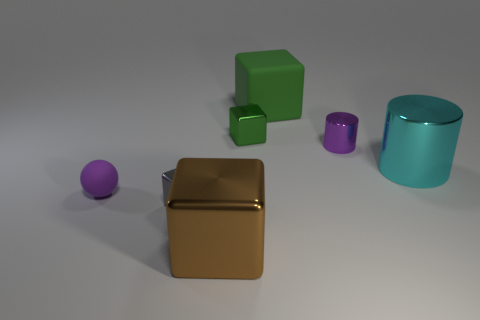Add 1 cyan metallic cylinders. How many objects exist? 8 Subtract all blocks. How many objects are left? 3 Add 3 gray blocks. How many gray blocks exist? 4 Subtract 1 cyan cylinders. How many objects are left? 6 Subtract all large green matte spheres. Subtract all small green things. How many objects are left? 6 Add 6 tiny gray blocks. How many tiny gray blocks are left? 7 